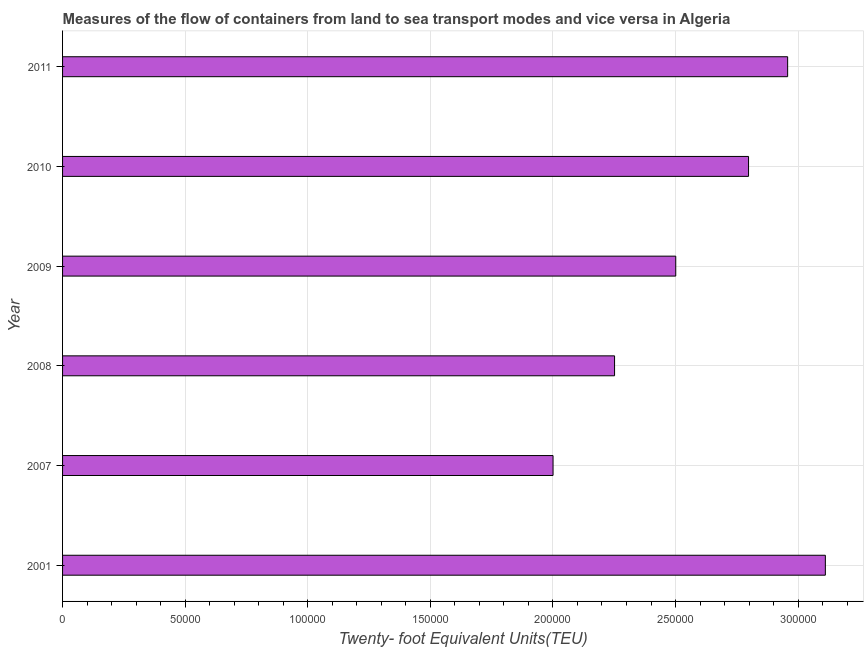Does the graph contain grids?
Ensure brevity in your answer.  Yes. What is the title of the graph?
Keep it short and to the point. Measures of the flow of containers from land to sea transport modes and vice versa in Algeria. What is the label or title of the X-axis?
Offer a terse response. Twenty- foot Equivalent Units(TEU). What is the container port traffic in 2011?
Provide a succinct answer. 2.96e+05. Across all years, what is the maximum container port traffic?
Your response must be concise. 3.11e+05. Across all years, what is the minimum container port traffic?
Your response must be concise. 2.00e+05. In which year was the container port traffic maximum?
Keep it short and to the point. 2001. In which year was the container port traffic minimum?
Your response must be concise. 2007. What is the sum of the container port traffic?
Provide a short and direct response. 1.56e+06. What is the difference between the container port traffic in 2008 and 2011?
Offer a very short reply. -7.06e+04. What is the average container port traffic per year?
Provide a succinct answer. 2.60e+05. What is the median container port traffic?
Ensure brevity in your answer.  2.65e+05. In how many years, is the container port traffic greater than 300000 TEU?
Your answer should be very brief. 1. Do a majority of the years between 2009 and 2007 (inclusive) have container port traffic greater than 130000 TEU?
Your answer should be very brief. Yes. What is the ratio of the container port traffic in 2001 to that in 2010?
Ensure brevity in your answer.  1.11. What is the difference between the highest and the second highest container port traffic?
Offer a very short reply. 1.54e+04. Is the sum of the container port traffic in 2007 and 2008 greater than the maximum container port traffic across all years?
Make the answer very short. Yes. What is the difference between the highest and the lowest container port traffic?
Give a very brief answer. 1.11e+05. How many bars are there?
Provide a short and direct response. 6. Are all the bars in the graph horizontal?
Keep it short and to the point. Yes. How many years are there in the graph?
Provide a short and direct response. 6. What is the difference between two consecutive major ticks on the X-axis?
Keep it short and to the point. 5.00e+04. Are the values on the major ticks of X-axis written in scientific E-notation?
Keep it short and to the point. No. What is the Twenty- foot Equivalent Units(TEU) of 2001?
Provide a short and direct response. 3.11e+05. What is the Twenty- foot Equivalent Units(TEU) in 2007?
Ensure brevity in your answer.  2.00e+05. What is the Twenty- foot Equivalent Units(TEU) of 2008?
Make the answer very short. 2.25e+05. What is the Twenty- foot Equivalent Units(TEU) of 2009?
Make the answer very short. 2.50e+05. What is the Twenty- foot Equivalent Units(TEU) in 2010?
Ensure brevity in your answer.  2.80e+05. What is the Twenty- foot Equivalent Units(TEU) of 2011?
Give a very brief answer. 2.96e+05. What is the difference between the Twenty- foot Equivalent Units(TEU) in 2001 and 2007?
Offer a very short reply. 1.11e+05. What is the difference between the Twenty- foot Equivalent Units(TEU) in 2001 and 2008?
Offer a very short reply. 8.60e+04. What is the difference between the Twenty- foot Equivalent Units(TEU) in 2001 and 2009?
Your answer should be compact. 6.10e+04. What is the difference between the Twenty- foot Equivalent Units(TEU) in 2001 and 2010?
Offer a terse response. 3.13e+04. What is the difference between the Twenty- foot Equivalent Units(TEU) in 2001 and 2011?
Your answer should be very brief. 1.54e+04. What is the difference between the Twenty- foot Equivalent Units(TEU) in 2007 and 2008?
Your answer should be compact. -2.51e+04. What is the difference between the Twenty- foot Equivalent Units(TEU) in 2007 and 2009?
Your response must be concise. -5.00e+04. What is the difference between the Twenty- foot Equivalent Units(TEU) in 2007 and 2010?
Offer a terse response. -7.97e+04. What is the difference between the Twenty- foot Equivalent Units(TEU) in 2007 and 2011?
Make the answer very short. -9.57e+04. What is the difference between the Twenty- foot Equivalent Units(TEU) in 2008 and 2009?
Your answer should be compact. -2.50e+04. What is the difference between the Twenty- foot Equivalent Units(TEU) in 2008 and 2010?
Make the answer very short. -5.46e+04. What is the difference between the Twenty- foot Equivalent Units(TEU) in 2008 and 2011?
Make the answer very short. -7.06e+04. What is the difference between the Twenty- foot Equivalent Units(TEU) in 2009 and 2010?
Your response must be concise. -2.97e+04. What is the difference between the Twenty- foot Equivalent Units(TEU) in 2009 and 2011?
Provide a short and direct response. -4.56e+04. What is the difference between the Twenty- foot Equivalent Units(TEU) in 2010 and 2011?
Your answer should be very brief. -1.59e+04. What is the ratio of the Twenty- foot Equivalent Units(TEU) in 2001 to that in 2007?
Give a very brief answer. 1.55. What is the ratio of the Twenty- foot Equivalent Units(TEU) in 2001 to that in 2008?
Ensure brevity in your answer.  1.38. What is the ratio of the Twenty- foot Equivalent Units(TEU) in 2001 to that in 2009?
Keep it short and to the point. 1.24. What is the ratio of the Twenty- foot Equivalent Units(TEU) in 2001 to that in 2010?
Your answer should be compact. 1.11. What is the ratio of the Twenty- foot Equivalent Units(TEU) in 2001 to that in 2011?
Provide a short and direct response. 1.05. What is the ratio of the Twenty- foot Equivalent Units(TEU) in 2007 to that in 2008?
Give a very brief answer. 0.89. What is the ratio of the Twenty- foot Equivalent Units(TEU) in 2007 to that in 2009?
Make the answer very short. 0.8. What is the ratio of the Twenty- foot Equivalent Units(TEU) in 2007 to that in 2010?
Your answer should be very brief. 0.71. What is the ratio of the Twenty- foot Equivalent Units(TEU) in 2007 to that in 2011?
Keep it short and to the point. 0.68. What is the ratio of the Twenty- foot Equivalent Units(TEU) in 2008 to that in 2010?
Your answer should be very brief. 0.81. What is the ratio of the Twenty- foot Equivalent Units(TEU) in 2008 to that in 2011?
Provide a short and direct response. 0.76. What is the ratio of the Twenty- foot Equivalent Units(TEU) in 2009 to that in 2010?
Ensure brevity in your answer.  0.89. What is the ratio of the Twenty- foot Equivalent Units(TEU) in 2009 to that in 2011?
Give a very brief answer. 0.85. What is the ratio of the Twenty- foot Equivalent Units(TEU) in 2010 to that in 2011?
Keep it short and to the point. 0.95. 